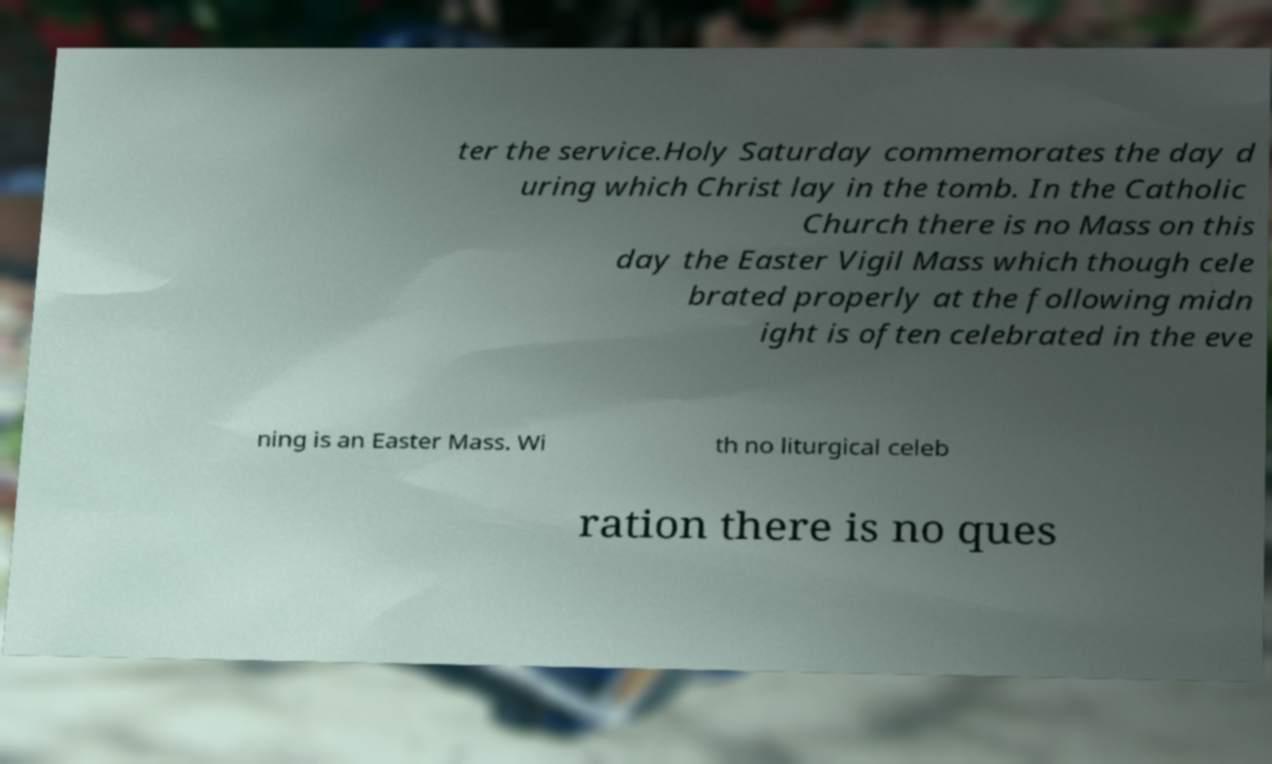There's text embedded in this image that I need extracted. Can you transcribe it verbatim? ter the service.Holy Saturday commemorates the day d uring which Christ lay in the tomb. In the Catholic Church there is no Mass on this day the Easter Vigil Mass which though cele brated properly at the following midn ight is often celebrated in the eve ning is an Easter Mass. Wi th no liturgical celeb ration there is no ques 